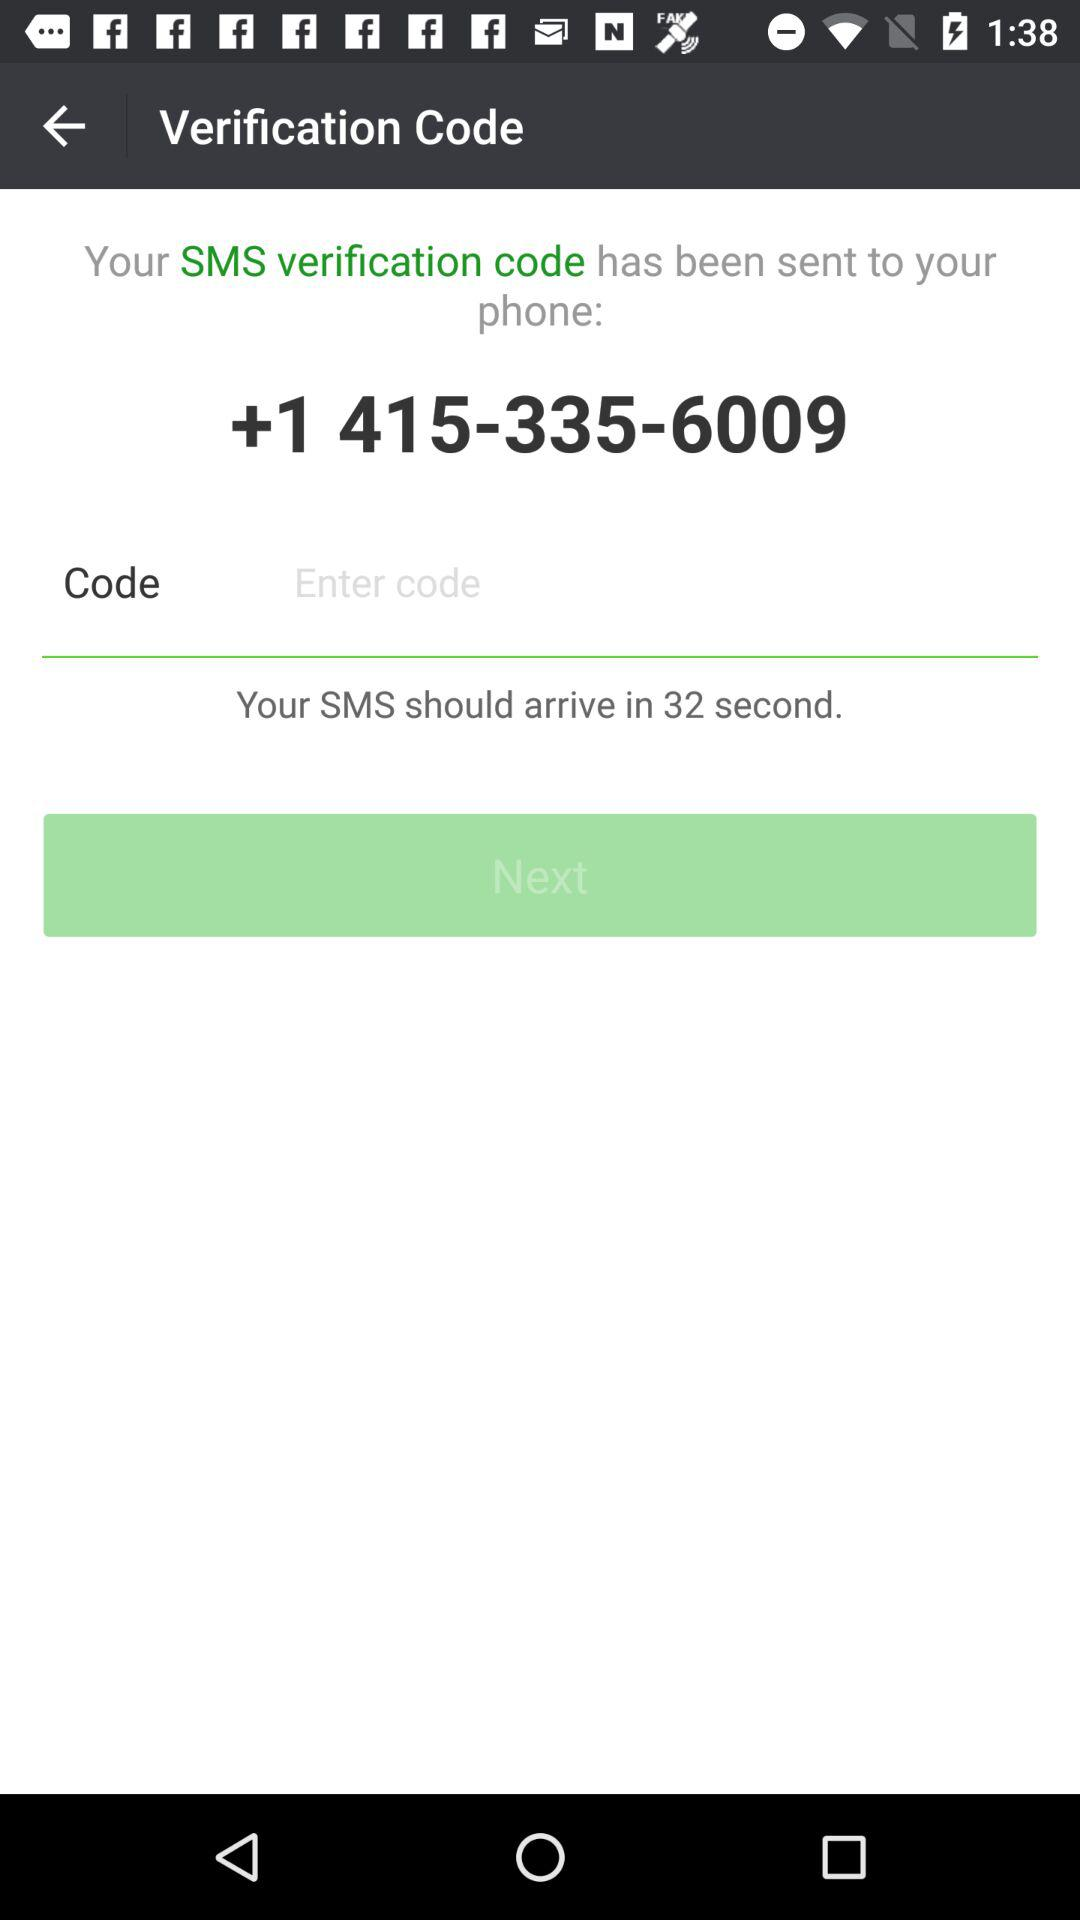What is the verification code?
When the provided information is insufficient, respond with <no answer>. <no answer> 